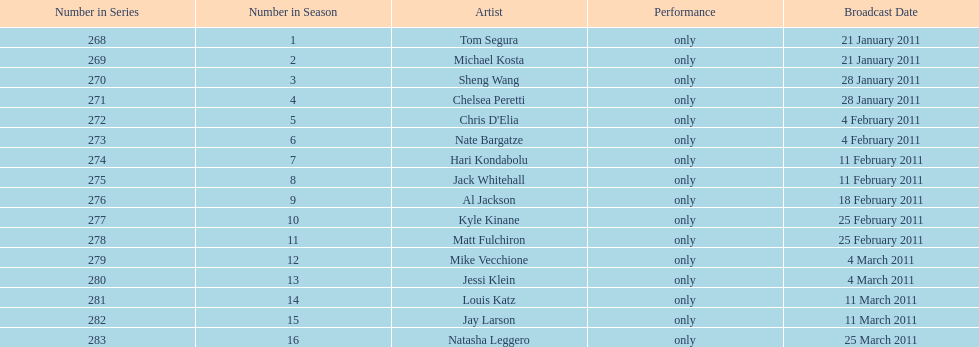Did al jackson air before or after kyle kinane? Before. 